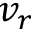<formula> <loc_0><loc_0><loc_500><loc_500>v _ { r }</formula> 